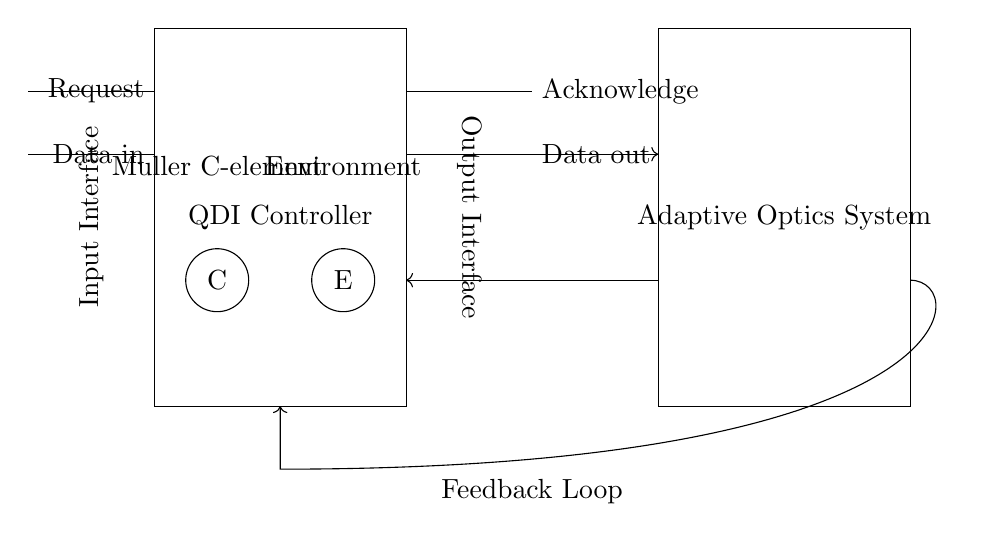What is the main function of the QDI Controller? The QDI Controller manages and facilitates communication between external requests and the adaptive optics system.
Answer: Communication management What does the Muller C-element do in this circuit? The Muller C-element serves as a synchronization element that controls the output based on its inputs, ensuring that the signals are only acknowledged when both inputs are present.
Answer: Synchronization What type of system is represented in the right block? The right block represents an adaptive optics system which adjusts in real-time to enhance image quality.
Answer: Adaptive optics How many input signals are there to the QDI Controller? There are two input signals: Request and Data in, both originating from the left side of the controller.
Answer: Two What is the feedback loop's purpose in the circuit? The feedback loop allows for information from the adaptive optics system to be sent back to the controller, enabling adjustments based on the output performance.
Answer: Information adjustment Which component is labeled as having an environmental interface? The component indicated as having an environmental interface is labeled simply as "Environment," which connects to the C-element in the controller.
Answer: Environment What is the relationship between the Data out and Data in signals? Data out is the output signal that represents the processed information from Data in, indicating a one-way data flow from input to output.
Answer: One-way flow 